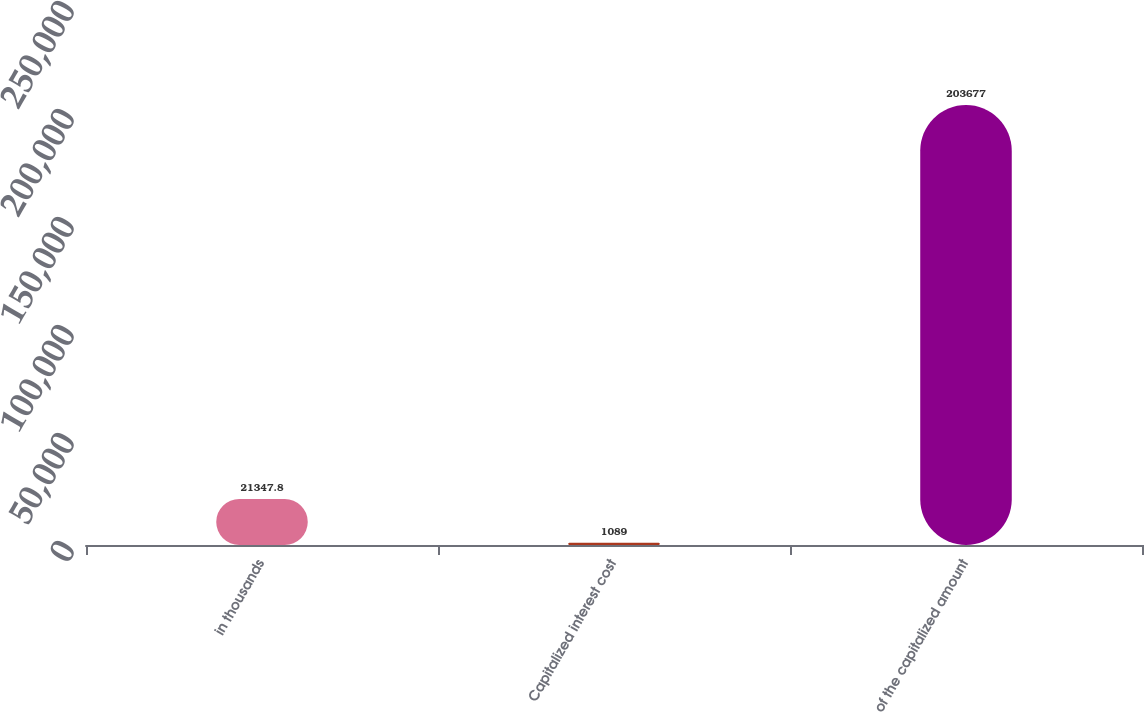Convert chart. <chart><loc_0><loc_0><loc_500><loc_500><bar_chart><fcel>in thousands<fcel>Capitalized interest cost<fcel>of the capitalized amount<nl><fcel>21347.8<fcel>1089<fcel>203677<nl></chart> 